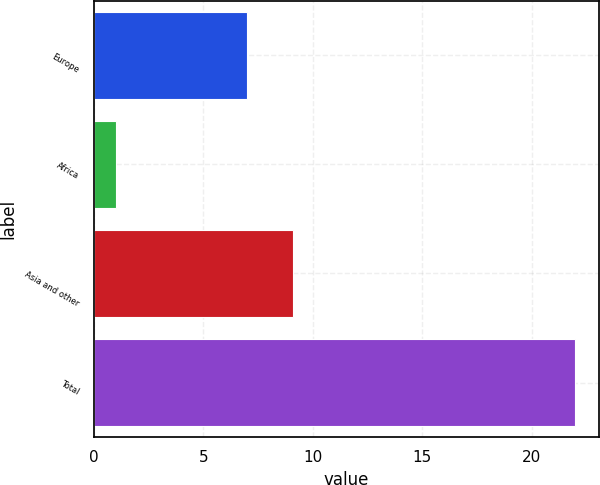Convert chart to OTSL. <chart><loc_0><loc_0><loc_500><loc_500><bar_chart><fcel>Europe<fcel>Africa<fcel>Asia and other<fcel>Total<nl><fcel>7<fcel>1<fcel>9.1<fcel>22<nl></chart> 